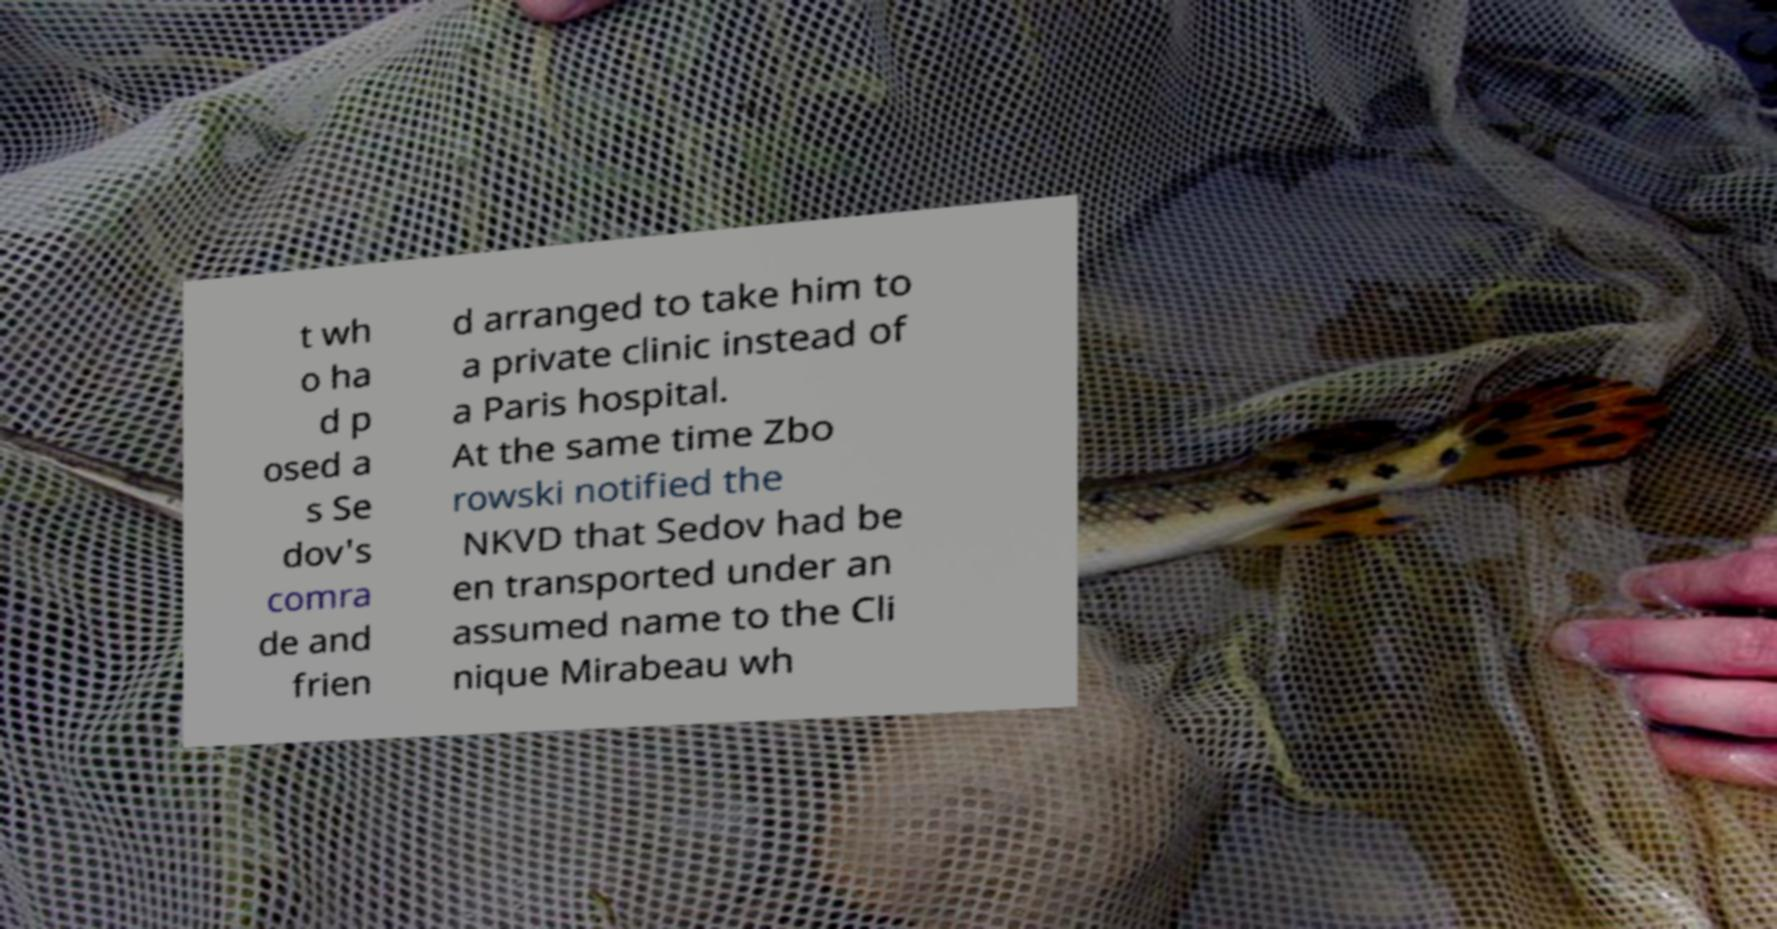Could you extract and type out the text from this image? t wh o ha d p osed a s Se dov's comra de and frien d arranged to take him to a private clinic instead of a Paris hospital. At the same time Zbo rowski notified the NKVD that Sedov had be en transported under an assumed name to the Cli nique Mirabeau wh 